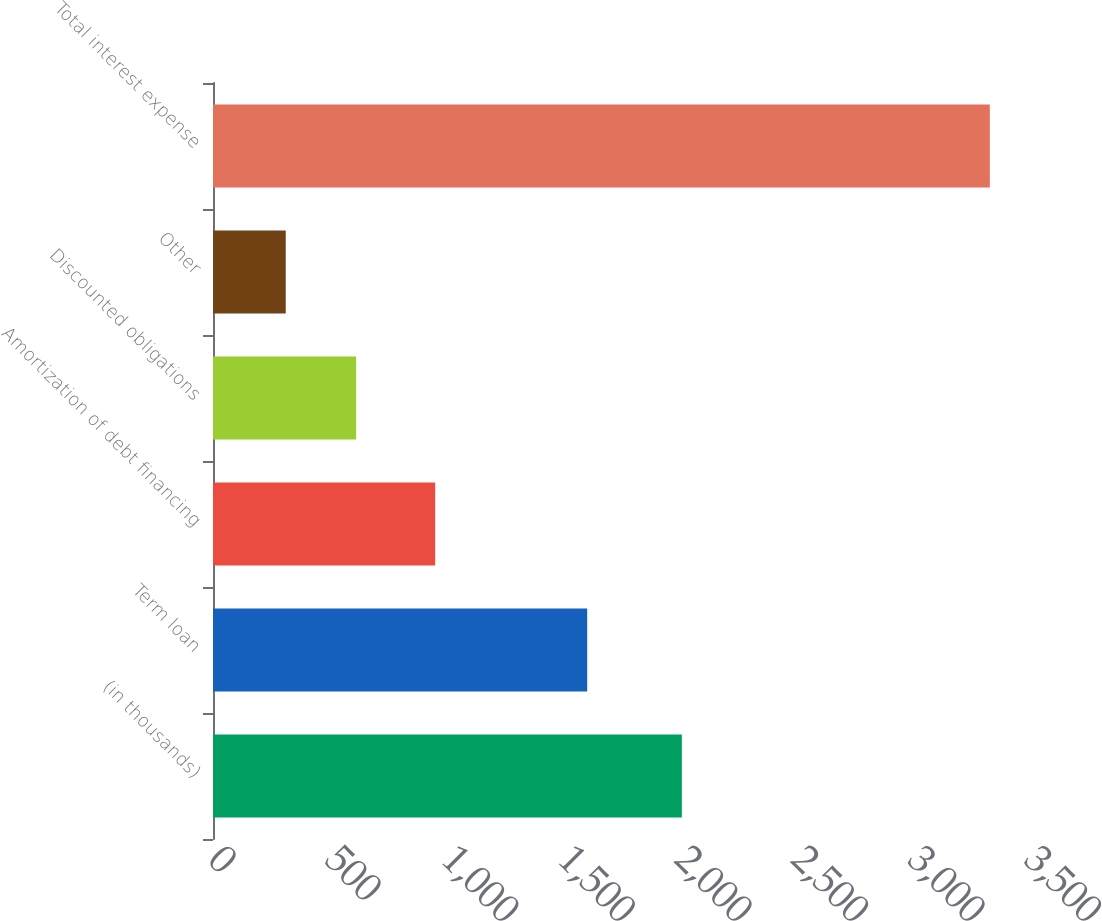Convert chart. <chart><loc_0><loc_0><loc_500><loc_500><bar_chart><fcel>(in thousands)<fcel>Term loan<fcel>Amortization of debt financing<fcel>Discounted obligations<fcel>Other<fcel>Total interest expense<nl><fcel>2011<fcel>1605<fcel>953<fcel>614<fcel>312<fcel>3332<nl></chart> 